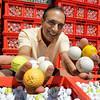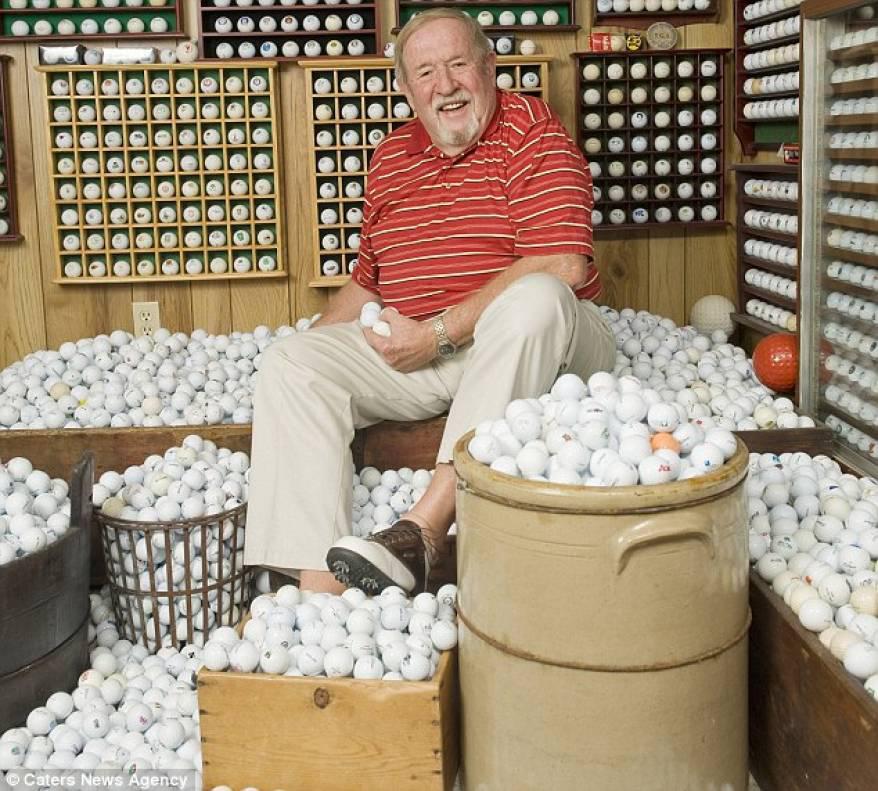The first image is the image on the left, the second image is the image on the right. Analyze the images presented: Is the assertion "There are so many golf balls; much more than twenty." valid? Answer yes or no. Yes. The first image is the image on the left, the second image is the image on the right. Assess this claim about the two images: "A person is sitting by golf balls in one of the images.". Correct or not? Answer yes or no. Yes. 